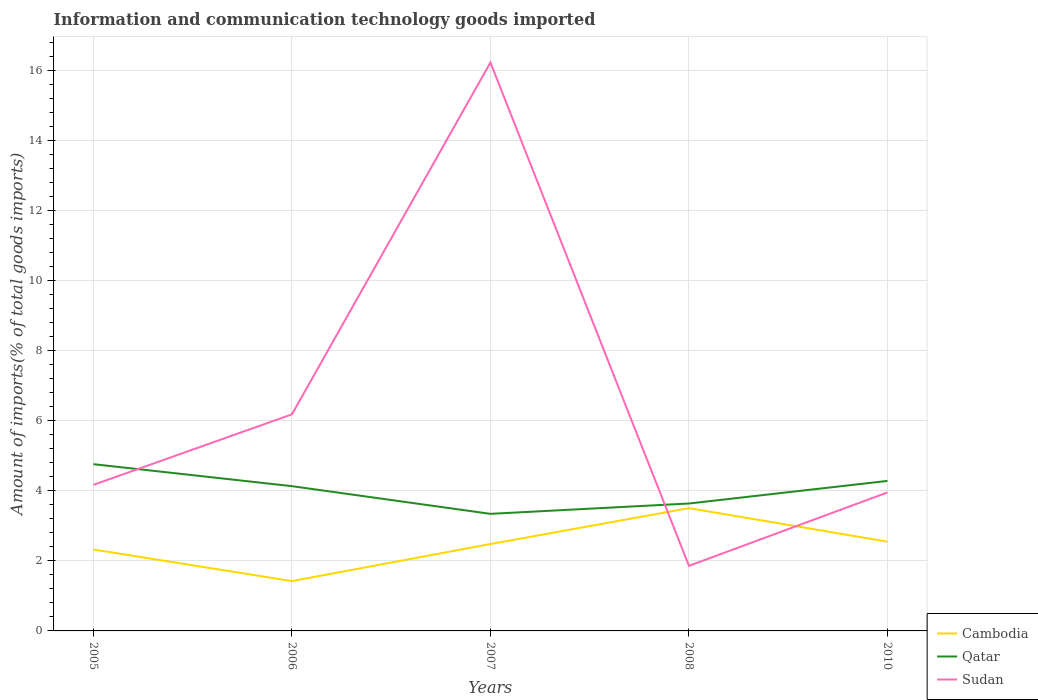Is the number of lines equal to the number of legend labels?
Offer a terse response. Yes. Across all years, what is the maximum amount of goods imported in Qatar?
Ensure brevity in your answer.  3.34. What is the total amount of goods imported in Qatar in the graph?
Offer a terse response. 0.48. What is the difference between the highest and the second highest amount of goods imported in Sudan?
Your response must be concise. 14.36. Is the amount of goods imported in Sudan strictly greater than the amount of goods imported in Qatar over the years?
Offer a very short reply. No. How many lines are there?
Keep it short and to the point. 3. How many years are there in the graph?
Provide a short and direct response. 5. Are the values on the major ticks of Y-axis written in scientific E-notation?
Your response must be concise. No. Does the graph contain any zero values?
Offer a very short reply. No. Does the graph contain grids?
Give a very brief answer. Yes. How are the legend labels stacked?
Make the answer very short. Vertical. What is the title of the graph?
Give a very brief answer. Information and communication technology goods imported. What is the label or title of the Y-axis?
Offer a terse response. Amount of imports(% of total goods imports). What is the Amount of imports(% of total goods imports) of Cambodia in 2005?
Your answer should be very brief. 2.32. What is the Amount of imports(% of total goods imports) of Qatar in 2005?
Offer a very short reply. 4.76. What is the Amount of imports(% of total goods imports) of Sudan in 2005?
Your response must be concise. 4.17. What is the Amount of imports(% of total goods imports) of Cambodia in 2006?
Make the answer very short. 1.42. What is the Amount of imports(% of total goods imports) in Qatar in 2006?
Keep it short and to the point. 4.13. What is the Amount of imports(% of total goods imports) in Sudan in 2006?
Your answer should be compact. 6.18. What is the Amount of imports(% of total goods imports) in Cambodia in 2007?
Offer a terse response. 2.48. What is the Amount of imports(% of total goods imports) of Qatar in 2007?
Your answer should be very brief. 3.34. What is the Amount of imports(% of total goods imports) of Sudan in 2007?
Ensure brevity in your answer.  16.22. What is the Amount of imports(% of total goods imports) in Cambodia in 2008?
Ensure brevity in your answer.  3.5. What is the Amount of imports(% of total goods imports) of Qatar in 2008?
Your answer should be very brief. 3.64. What is the Amount of imports(% of total goods imports) of Sudan in 2008?
Give a very brief answer. 1.86. What is the Amount of imports(% of total goods imports) in Cambodia in 2010?
Provide a short and direct response. 2.55. What is the Amount of imports(% of total goods imports) of Qatar in 2010?
Ensure brevity in your answer.  4.28. What is the Amount of imports(% of total goods imports) of Sudan in 2010?
Offer a very short reply. 3.95. Across all years, what is the maximum Amount of imports(% of total goods imports) of Cambodia?
Ensure brevity in your answer.  3.5. Across all years, what is the maximum Amount of imports(% of total goods imports) in Qatar?
Ensure brevity in your answer.  4.76. Across all years, what is the maximum Amount of imports(% of total goods imports) of Sudan?
Ensure brevity in your answer.  16.22. Across all years, what is the minimum Amount of imports(% of total goods imports) of Cambodia?
Make the answer very short. 1.42. Across all years, what is the minimum Amount of imports(% of total goods imports) in Qatar?
Your answer should be very brief. 3.34. Across all years, what is the minimum Amount of imports(% of total goods imports) of Sudan?
Offer a terse response. 1.86. What is the total Amount of imports(% of total goods imports) of Cambodia in the graph?
Your answer should be very brief. 12.27. What is the total Amount of imports(% of total goods imports) in Qatar in the graph?
Make the answer very short. 20.14. What is the total Amount of imports(% of total goods imports) of Sudan in the graph?
Keep it short and to the point. 32.37. What is the difference between the Amount of imports(% of total goods imports) in Cambodia in 2005 and that in 2006?
Your response must be concise. 0.9. What is the difference between the Amount of imports(% of total goods imports) in Qatar in 2005 and that in 2006?
Your answer should be very brief. 0.63. What is the difference between the Amount of imports(% of total goods imports) in Sudan in 2005 and that in 2006?
Provide a short and direct response. -2.01. What is the difference between the Amount of imports(% of total goods imports) of Cambodia in 2005 and that in 2007?
Offer a terse response. -0.16. What is the difference between the Amount of imports(% of total goods imports) of Qatar in 2005 and that in 2007?
Your response must be concise. 1.42. What is the difference between the Amount of imports(% of total goods imports) of Sudan in 2005 and that in 2007?
Make the answer very short. -12.05. What is the difference between the Amount of imports(% of total goods imports) in Cambodia in 2005 and that in 2008?
Your answer should be very brief. -1.18. What is the difference between the Amount of imports(% of total goods imports) in Qatar in 2005 and that in 2008?
Your answer should be very brief. 1.12. What is the difference between the Amount of imports(% of total goods imports) in Sudan in 2005 and that in 2008?
Offer a terse response. 2.31. What is the difference between the Amount of imports(% of total goods imports) in Cambodia in 2005 and that in 2010?
Your response must be concise. -0.22. What is the difference between the Amount of imports(% of total goods imports) in Qatar in 2005 and that in 2010?
Keep it short and to the point. 0.48. What is the difference between the Amount of imports(% of total goods imports) of Sudan in 2005 and that in 2010?
Offer a terse response. 0.22. What is the difference between the Amount of imports(% of total goods imports) of Cambodia in 2006 and that in 2007?
Keep it short and to the point. -1.06. What is the difference between the Amount of imports(% of total goods imports) in Qatar in 2006 and that in 2007?
Keep it short and to the point. 0.79. What is the difference between the Amount of imports(% of total goods imports) in Sudan in 2006 and that in 2007?
Keep it short and to the point. -10.04. What is the difference between the Amount of imports(% of total goods imports) of Cambodia in 2006 and that in 2008?
Your answer should be compact. -2.08. What is the difference between the Amount of imports(% of total goods imports) of Qatar in 2006 and that in 2008?
Provide a short and direct response. 0.49. What is the difference between the Amount of imports(% of total goods imports) in Sudan in 2006 and that in 2008?
Give a very brief answer. 4.32. What is the difference between the Amount of imports(% of total goods imports) in Cambodia in 2006 and that in 2010?
Your answer should be very brief. -1.12. What is the difference between the Amount of imports(% of total goods imports) of Qatar in 2006 and that in 2010?
Offer a very short reply. -0.15. What is the difference between the Amount of imports(% of total goods imports) of Sudan in 2006 and that in 2010?
Your answer should be compact. 2.23. What is the difference between the Amount of imports(% of total goods imports) in Cambodia in 2007 and that in 2008?
Make the answer very short. -1.02. What is the difference between the Amount of imports(% of total goods imports) of Qatar in 2007 and that in 2008?
Your answer should be very brief. -0.3. What is the difference between the Amount of imports(% of total goods imports) of Sudan in 2007 and that in 2008?
Give a very brief answer. 14.36. What is the difference between the Amount of imports(% of total goods imports) in Cambodia in 2007 and that in 2010?
Offer a very short reply. -0.07. What is the difference between the Amount of imports(% of total goods imports) in Qatar in 2007 and that in 2010?
Provide a succinct answer. -0.94. What is the difference between the Amount of imports(% of total goods imports) in Sudan in 2007 and that in 2010?
Your answer should be very brief. 12.27. What is the difference between the Amount of imports(% of total goods imports) of Cambodia in 2008 and that in 2010?
Offer a terse response. 0.96. What is the difference between the Amount of imports(% of total goods imports) in Qatar in 2008 and that in 2010?
Your answer should be very brief. -0.64. What is the difference between the Amount of imports(% of total goods imports) in Sudan in 2008 and that in 2010?
Your answer should be very brief. -2.09. What is the difference between the Amount of imports(% of total goods imports) of Cambodia in 2005 and the Amount of imports(% of total goods imports) of Qatar in 2006?
Your answer should be compact. -1.81. What is the difference between the Amount of imports(% of total goods imports) of Cambodia in 2005 and the Amount of imports(% of total goods imports) of Sudan in 2006?
Offer a terse response. -3.86. What is the difference between the Amount of imports(% of total goods imports) of Qatar in 2005 and the Amount of imports(% of total goods imports) of Sudan in 2006?
Provide a short and direct response. -1.42. What is the difference between the Amount of imports(% of total goods imports) of Cambodia in 2005 and the Amount of imports(% of total goods imports) of Qatar in 2007?
Keep it short and to the point. -1.02. What is the difference between the Amount of imports(% of total goods imports) of Cambodia in 2005 and the Amount of imports(% of total goods imports) of Sudan in 2007?
Offer a terse response. -13.89. What is the difference between the Amount of imports(% of total goods imports) of Qatar in 2005 and the Amount of imports(% of total goods imports) of Sudan in 2007?
Provide a short and direct response. -11.46. What is the difference between the Amount of imports(% of total goods imports) of Cambodia in 2005 and the Amount of imports(% of total goods imports) of Qatar in 2008?
Make the answer very short. -1.31. What is the difference between the Amount of imports(% of total goods imports) of Cambodia in 2005 and the Amount of imports(% of total goods imports) of Sudan in 2008?
Offer a very short reply. 0.47. What is the difference between the Amount of imports(% of total goods imports) of Qatar in 2005 and the Amount of imports(% of total goods imports) of Sudan in 2008?
Your answer should be very brief. 2.9. What is the difference between the Amount of imports(% of total goods imports) of Cambodia in 2005 and the Amount of imports(% of total goods imports) of Qatar in 2010?
Make the answer very short. -1.96. What is the difference between the Amount of imports(% of total goods imports) of Cambodia in 2005 and the Amount of imports(% of total goods imports) of Sudan in 2010?
Provide a succinct answer. -1.63. What is the difference between the Amount of imports(% of total goods imports) of Qatar in 2005 and the Amount of imports(% of total goods imports) of Sudan in 2010?
Ensure brevity in your answer.  0.81. What is the difference between the Amount of imports(% of total goods imports) of Cambodia in 2006 and the Amount of imports(% of total goods imports) of Qatar in 2007?
Provide a succinct answer. -1.92. What is the difference between the Amount of imports(% of total goods imports) of Cambodia in 2006 and the Amount of imports(% of total goods imports) of Sudan in 2007?
Offer a terse response. -14.8. What is the difference between the Amount of imports(% of total goods imports) of Qatar in 2006 and the Amount of imports(% of total goods imports) of Sudan in 2007?
Your answer should be compact. -12.09. What is the difference between the Amount of imports(% of total goods imports) of Cambodia in 2006 and the Amount of imports(% of total goods imports) of Qatar in 2008?
Ensure brevity in your answer.  -2.21. What is the difference between the Amount of imports(% of total goods imports) of Cambodia in 2006 and the Amount of imports(% of total goods imports) of Sudan in 2008?
Give a very brief answer. -0.44. What is the difference between the Amount of imports(% of total goods imports) in Qatar in 2006 and the Amount of imports(% of total goods imports) in Sudan in 2008?
Your response must be concise. 2.27. What is the difference between the Amount of imports(% of total goods imports) in Cambodia in 2006 and the Amount of imports(% of total goods imports) in Qatar in 2010?
Ensure brevity in your answer.  -2.86. What is the difference between the Amount of imports(% of total goods imports) in Cambodia in 2006 and the Amount of imports(% of total goods imports) in Sudan in 2010?
Offer a very short reply. -2.53. What is the difference between the Amount of imports(% of total goods imports) of Qatar in 2006 and the Amount of imports(% of total goods imports) of Sudan in 2010?
Your response must be concise. 0.18. What is the difference between the Amount of imports(% of total goods imports) of Cambodia in 2007 and the Amount of imports(% of total goods imports) of Qatar in 2008?
Your answer should be very brief. -1.16. What is the difference between the Amount of imports(% of total goods imports) in Cambodia in 2007 and the Amount of imports(% of total goods imports) in Sudan in 2008?
Give a very brief answer. 0.62. What is the difference between the Amount of imports(% of total goods imports) in Qatar in 2007 and the Amount of imports(% of total goods imports) in Sudan in 2008?
Provide a succinct answer. 1.48. What is the difference between the Amount of imports(% of total goods imports) of Cambodia in 2007 and the Amount of imports(% of total goods imports) of Qatar in 2010?
Keep it short and to the point. -1.8. What is the difference between the Amount of imports(% of total goods imports) in Cambodia in 2007 and the Amount of imports(% of total goods imports) in Sudan in 2010?
Your answer should be compact. -1.47. What is the difference between the Amount of imports(% of total goods imports) in Qatar in 2007 and the Amount of imports(% of total goods imports) in Sudan in 2010?
Your response must be concise. -0.61. What is the difference between the Amount of imports(% of total goods imports) in Cambodia in 2008 and the Amount of imports(% of total goods imports) in Qatar in 2010?
Your response must be concise. -0.78. What is the difference between the Amount of imports(% of total goods imports) in Cambodia in 2008 and the Amount of imports(% of total goods imports) in Sudan in 2010?
Your answer should be compact. -0.45. What is the difference between the Amount of imports(% of total goods imports) of Qatar in 2008 and the Amount of imports(% of total goods imports) of Sudan in 2010?
Offer a very short reply. -0.32. What is the average Amount of imports(% of total goods imports) of Cambodia per year?
Ensure brevity in your answer.  2.45. What is the average Amount of imports(% of total goods imports) of Qatar per year?
Keep it short and to the point. 4.03. What is the average Amount of imports(% of total goods imports) of Sudan per year?
Make the answer very short. 6.47. In the year 2005, what is the difference between the Amount of imports(% of total goods imports) of Cambodia and Amount of imports(% of total goods imports) of Qatar?
Make the answer very short. -2.43. In the year 2005, what is the difference between the Amount of imports(% of total goods imports) in Cambodia and Amount of imports(% of total goods imports) in Sudan?
Offer a terse response. -1.84. In the year 2005, what is the difference between the Amount of imports(% of total goods imports) in Qatar and Amount of imports(% of total goods imports) in Sudan?
Your answer should be compact. 0.59. In the year 2006, what is the difference between the Amount of imports(% of total goods imports) in Cambodia and Amount of imports(% of total goods imports) in Qatar?
Provide a succinct answer. -2.71. In the year 2006, what is the difference between the Amount of imports(% of total goods imports) of Cambodia and Amount of imports(% of total goods imports) of Sudan?
Your answer should be compact. -4.76. In the year 2006, what is the difference between the Amount of imports(% of total goods imports) of Qatar and Amount of imports(% of total goods imports) of Sudan?
Your answer should be very brief. -2.05. In the year 2007, what is the difference between the Amount of imports(% of total goods imports) in Cambodia and Amount of imports(% of total goods imports) in Qatar?
Your response must be concise. -0.86. In the year 2007, what is the difference between the Amount of imports(% of total goods imports) of Cambodia and Amount of imports(% of total goods imports) of Sudan?
Your response must be concise. -13.74. In the year 2007, what is the difference between the Amount of imports(% of total goods imports) in Qatar and Amount of imports(% of total goods imports) in Sudan?
Offer a terse response. -12.88. In the year 2008, what is the difference between the Amount of imports(% of total goods imports) of Cambodia and Amount of imports(% of total goods imports) of Qatar?
Your response must be concise. -0.13. In the year 2008, what is the difference between the Amount of imports(% of total goods imports) of Cambodia and Amount of imports(% of total goods imports) of Sudan?
Ensure brevity in your answer.  1.65. In the year 2008, what is the difference between the Amount of imports(% of total goods imports) in Qatar and Amount of imports(% of total goods imports) in Sudan?
Provide a short and direct response. 1.78. In the year 2010, what is the difference between the Amount of imports(% of total goods imports) in Cambodia and Amount of imports(% of total goods imports) in Qatar?
Offer a very short reply. -1.73. In the year 2010, what is the difference between the Amount of imports(% of total goods imports) in Cambodia and Amount of imports(% of total goods imports) in Sudan?
Make the answer very short. -1.4. In the year 2010, what is the difference between the Amount of imports(% of total goods imports) in Qatar and Amount of imports(% of total goods imports) in Sudan?
Give a very brief answer. 0.33. What is the ratio of the Amount of imports(% of total goods imports) of Cambodia in 2005 to that in 2006?
Give a very brief answer. 1.63. What is the ratio of the Amount of imports(% of total goods imports) in Qatar in 2005 to that in 2006?
Offer a very short reply. 1.15. What is the ratio of the Amount of imports(% of total goods imports) of Sudan in 2005 to that in 2006?
Provide a short and direct response. 0.67. What is the ratio of the Amount of imports(% of total goods imports) of Cambodia in 2005 to that in 2007?
Your answer should be compact. 0.94. What is the ratio of the Amount of imports(% of total goods imports) in Qatar in 2005 to that in 2007?
Your response must be concise. 1.42. What is the ratio of the Amount of imports(% of total goods imports) in Sudan in 2005 to that in 2007?
Provide a succinct answer. 0.26. What is the ratio of the Amount of imports(% of total goods imports) of Cambodia in 2005 to that in 2008?
Your response must be concise. 0.66. What is the ratio of the Amount of imports(% of total goods imports) of Qatar in 2005 to that in 2008?
Provide a succinct answer. 1.31. What is the ratio of the Amount of imports(% of total goods imports) of Sudan in 2005 to that in 2008?
Offer a very short reply. 2.24. What is the ratio of the Amount of imports(% of total goods imports) in Cambodia in 2005 to that in 2010?
Your answer should be compact. 0.91. What is the ratio of the Amount of imports(% of total goods imports) in Qatar in 2005 to that in 2010?
Ensure brevity in your answer.  1.11. What is the ratio of the Amount of imports(% of total goods imports) in Sudan in 2005 to that in 2010?
Your answer should be compact. 1.05. What is the ratio of the Amount of imports(% of total goods imports) of Cambodia in 2006 to that in 2007?
Offer a terse response. 0.57. What is the ratio of the Amount of imports(% of total goods imports) in Qatar in 2006 to that in 2007?
Offer a terse response. 1.24. What is the ratio of the Amount of imports(% of total goods imports) in Sudan in 2006 to that in 2007?
Your response must be concise. 0.38. What is the ratio of the Amount of imports(% of total goods imports) of Cambodia in 2006 to that in 2008?
Give a very brief answer. 0.41. What is the ratio of the Amount of imports(% of total goods imports) in Qatar in 2006 to that in 2008?
Keep it short and to the point. 1.14. What is the ratio of the Amount of imports(% of total goods imports) in Sudan in 2006 to that in 2008?
Provide a short and direct response. 3.33. What is the ratio of the Amount of imports(% of total goods imports) of Cambodia in 2006 to that in 2010?
Keep it short and to the point. 0.56. What is the ratio of the Amount of imports(% of total goods imports) of Qatar in 2006 to that in 2010?
Your answer should be compact. 0.96. What is the ratio of the Amount of imports(% of total goods imports) of Sudan in 2006 to that in 2010?
Give a very brief answer. 1.56. What is the ratio of the Amount of imports(% of total goods imports) of Cambodia in 2007 to that in 2008?
Give a very brief answer. 0.71. What is the ratio of the Amount of imports(% of total goods imports) in Qatar in 2007 to that in 2008?
Offer a very short reply. 0.92. What is the ratio of the Amount of imports(% of total goods imports) in Sudan in 2007 to that in 2008?
Your answer should be compact. 8.73. What is the ratio of the Amount of imports(% of total goods imports) in Cambodia in 2007 to that in 2010?
Provide a succinct answer. 0.97. What is the ratio of the Amount of imports(% of total goods imports) in Qatar in 2007 to that in 2010?
Provide a short and direct response. 0.78. What is the ratio of the Amount of imports(% of total goods imports) of Sudan in 2007 to that in 2010?
Offer a terse response. 4.11. What is the ratio of the Amount of imports(% of total goods imports) in Cambodia in 2008 to that in 2010?
Give a very brief answer. 1.38. What is the ratio of the Amount of imports(% of total goods imports) of Qatar in 2008 to that in 2010?
Your answer should be compact. 0.85. What is the ratio of the Amount of imports(% of total goods imports) in Sudan in 2008 to that in 2010?
Make the answer very short. 0.47. What is the difference between the highest and the second highest Amount of imports(% of total goods imports) in Cambodia?
Give a very brief answer. 0.96. What is the difference between the highest and the second highest Amount of imports(% of total goods imports) of Qatar?
Offer a terse response. 0.48. What is the difference between the highest and the second highest Amount of imports(% of total goods imports) in Sudan?
Keep it short and to the point. 10.04. What is the difference between the highest and the lowest Amount of imports(% of total goods imports) of Cambodia?
Ensure brevity in your answer.  2.08. What is the difference between the highest and the lowest Amount of imports(% of total goods imports) in Qatar?
Your answer should be compact. 1.42. What is the difference between the highest and the lowest Amount of imports(% of total goods imports) in Sudan?
Your answer should be compact. 14.36. 